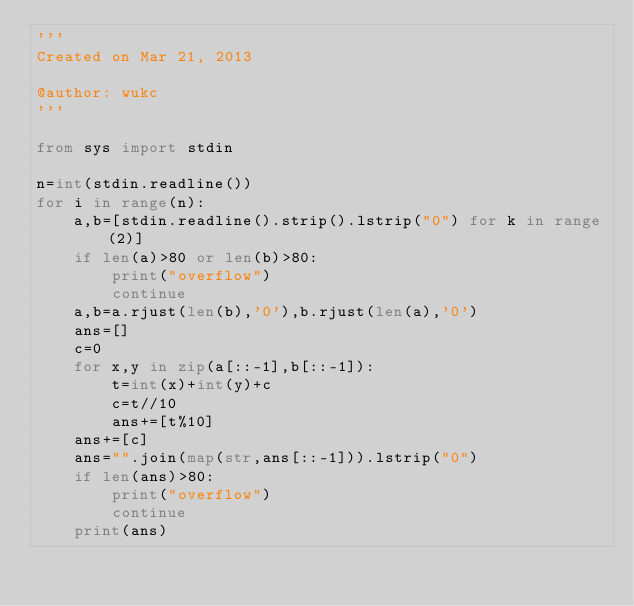<code> <loc_0><loc_0><loc_500><loc_500><_Python_>'''
Created on Mar 21, 2013

@author: wukc
'''

from sys import stdin

n=int(stdin.readline())
for i in range(n):
    a,b=[stdin.readline().strip().lstrip("0") for k in range(2)]
    if len(a)>80 or len(b)>80:
        print("overflow")
        continue
    a,b=a.rjust(len(b),'0'),b.rjust(len(a),'0')
    ans=[]
    c=0
    for x,y in zip(a[::-1],b[::-1]):
        t=int(x)+int(y)+c
        c=t//10
        ans+=[t%10]
    ans+=[c]
    ans="".join(map(str,ans[::-1])).lstrip("0")
    if len(ans)>80:
        print("overflow")
        continue
    print(ans)
    </code> 